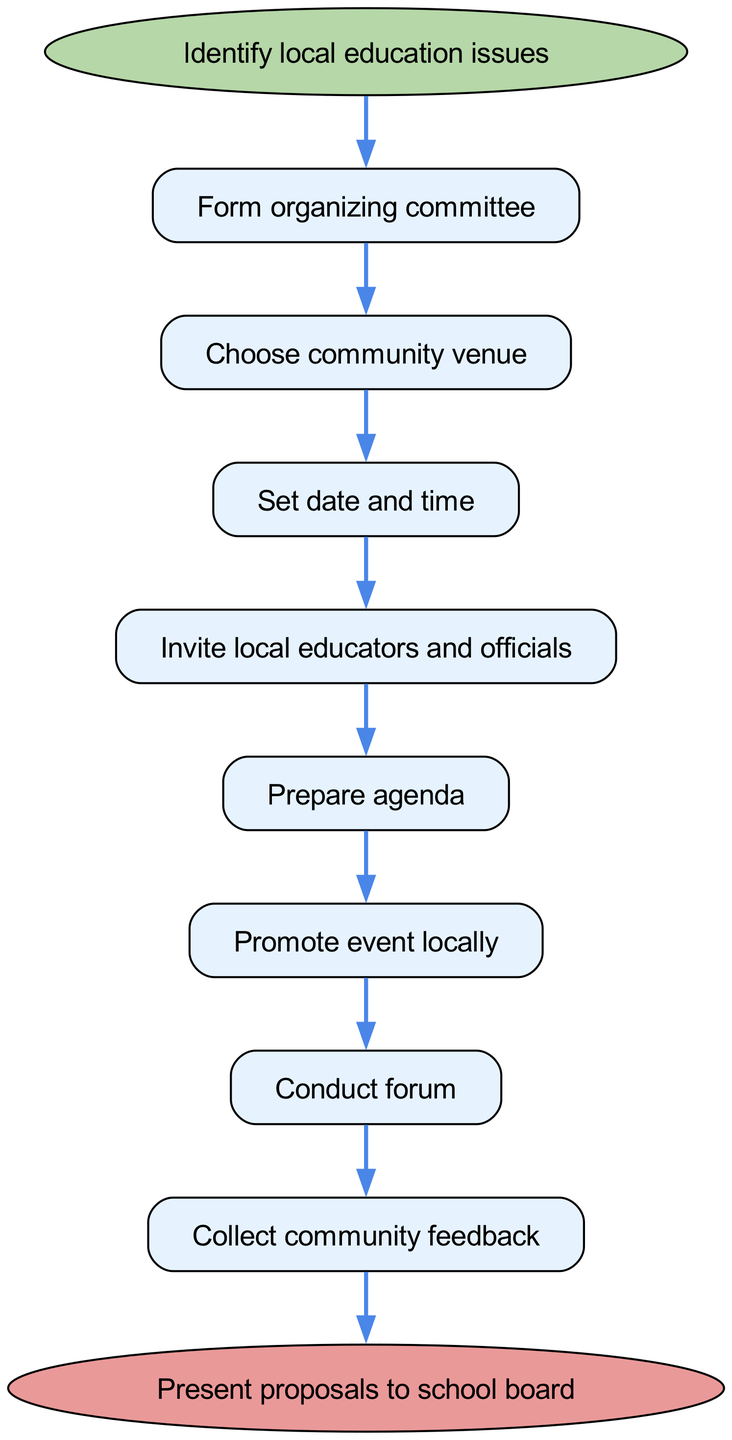What is the first step in organizing the forum? The first step, as indicated in the diagram, is to "Identify local education issues," which is the starting node of the flow.
Answer: Identify local education issues How many steps are there to organize the forum? Counting the steps within the diagram, there are eight distinct steps before reaching the end.
Answer: Eight What is the final action in the flow chart? The end node shows that the final action to be taken after collecting feedback is to "Present proposals to school board."
Answer: Present proposals to school board What step follows after inviting local educators and officials? According to the flow chart, the step that comes next after inviting local educators and officials is "Prepare agenda."
Answer: Prepare agenda Which steps are considered the beginning and end nodes in the diagram? The beginning node is "Identify local education issues," while the end node is "Present proposals to school board," representing the overall start and conclusion of the process.
Answer: Identify local education issues and Present proposals to school board How do the steps relate to each other? The steps are sequentially connected, meaning that each step directly leads into the next one, forming a linear process from beginning to end without parallel paths or branches.
Answer: Sequentially connected What action leads to conducting the forum? The penultimate step before conducting the forum is "Promote event locally." This indicates that promotion is essential to ensure the forum takes place.
Answer: Promote event locally Which step is preceded by setting the date and time? The step that immediately follows "Set date and time" is "Invite local educators and officials," indicating it's the next action to take.
Answer: Invite local educators and officials 